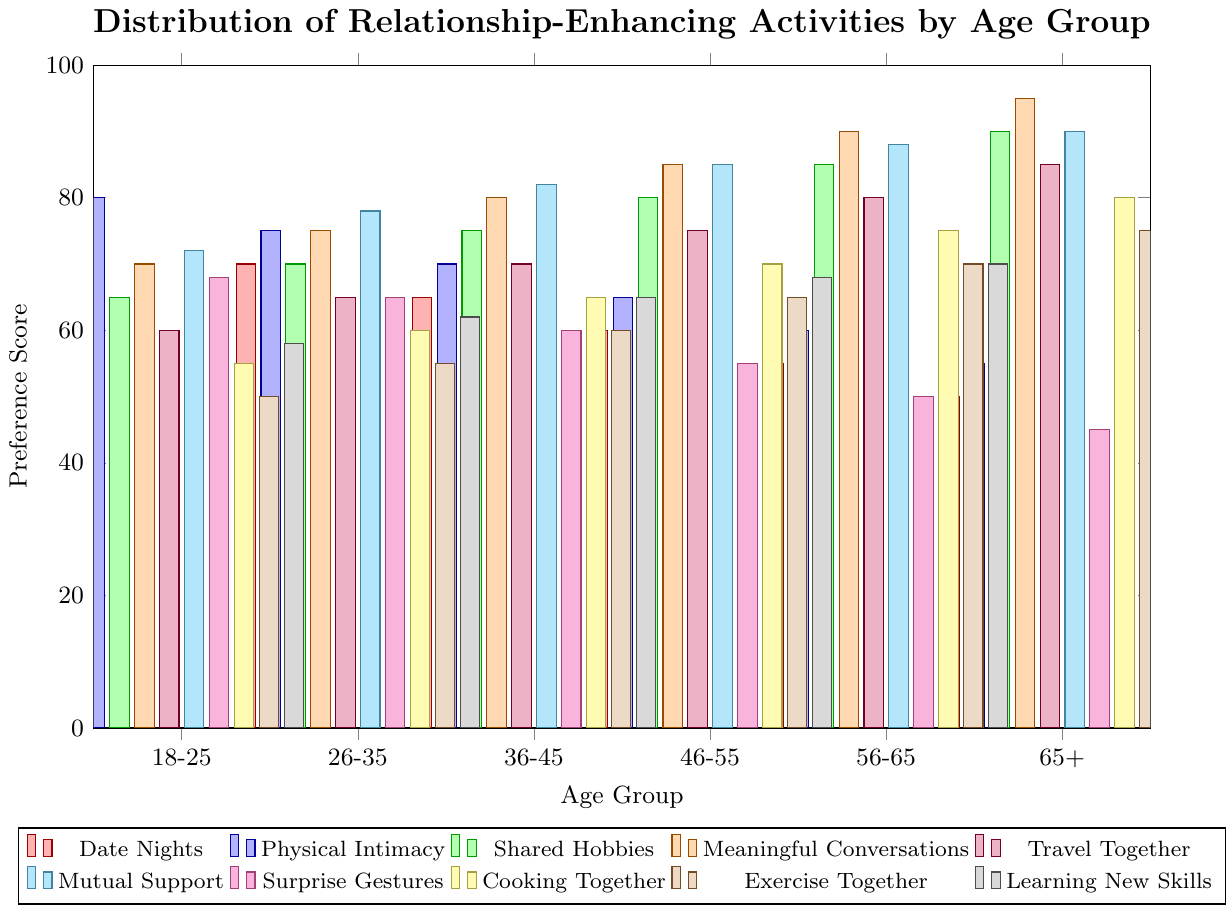Which age group has the highest preference for meaningful conversations? Check the bar for meaningful conversations for each age group and identify the highest one. The age group 65+ has a 95 preference score.
Answer: 65+ Which activity is least preferred by the 18-25 age group? Compare the bar heights for each activity in the 18-25 age group to find the smallest one. Exercise Together has the lowest score of 50.
Answer: Exercise Together What is the average preference score for Travel Together across all age groups? Sum the preference scores for Travel Together across all age groups and divide by the number of age groups (60 + 65 + 70 + 75 + 80 + 85) / 6.
Answer: 72.5 Compare the preference for shared hobbies between the 36-45 and 56-65 age groups. Which is higher? Check the heights of the bars for shared hobbies in the 36-45 and 56-65 age groups. 56-65 has a higher score (85 vs 75).
Answer: 56-65 Which age group has the most consistent preference scores across all activities? Calculate the range (maximum - minimum) of preference scores for each age group and find the smallest range. The range for 26-35 is 78-55=23, making it the most consistent.
Answer: 26-35 What is the total preference score for mutual support in the 26-35, 46-55, and 65+ age groups? Add the preference scores for mutual support in the specified age groups (78 + 85 + 90).
Answer: 253 Does any age group prefer surprise gestures over meaningful conversations? Compare the heights of the bars for surprise gestures and meaningful conversations within each age group. In all age groups, meaningful conversations have higher scores.
Answer: No Which two activities have the closest preference scores in the 46-55 age group? Find pairs of activities in the 46-55 age group with close preference scores. The closest pair is meaningful conversations (85) and travel together (75).
Answer: Meaningful Conversations and Travel Together How does the preference for cooking together change from the 18-25 age group to the 65+ age group? Subtract the preference score for cooking together in the 18-25 age group from that in the 65+ age group (80 - 55).
Answer: Increases by 25 What is the difference in the preference for physical intimacy between the youngest and oldest age groups? Subtract the preference score for physical intimacy in the 65+ age group from that in the 18-25 age group (80 - 55).
Answer: 25 